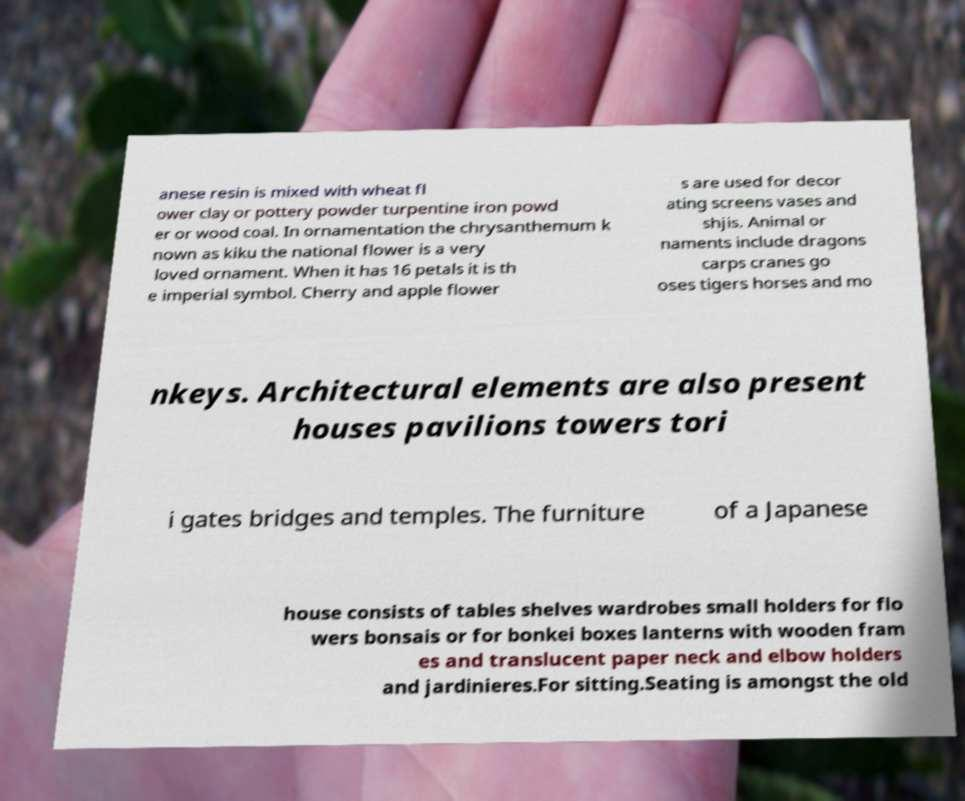For documentation purposes, I need the text within this image transcribed. Could you provide that? anese resin is mixed with wheat fl ower clay or pottery powder turpentine iron powd er or wood coal. In ornamentation the chrysanthemum k nown as kiku the national flower is a very loved ornament. When it has 16 petals it is th e imperial symbol. Cherry and apple flower s are used for decor ating screens vases and shjis. Animal or naments include dragons carps cranes go oses tigers horses and mo nkeys. Architectural elements are also present houses pavilions towers tori i gates bridges and temples. The furniture of a Japanese house consists of tables shelves wardrobes small holders for flo wers bonsais or for bonkei boxes lanterns with wooden fram es and translucent paper neck and elbow holders and jardinieres.For sitting.Seating is amongst the old 